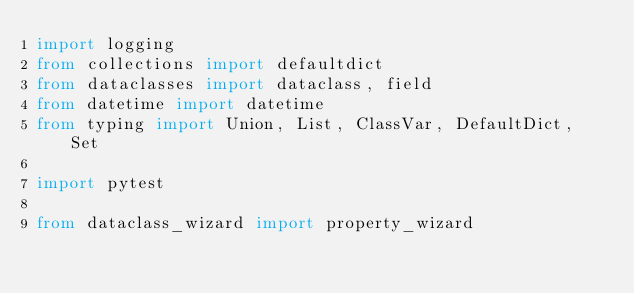<code> <loc_0><loc_0><loc_500><loc_500><_Python_>import logging
from collections import defaultdict
from dataclasses import dataclass, field
from datetime import datetime
from typing import Union, List, ClassVar, DefaultDict, Set

import pytest

from dataclass_wizard import property_wizard</code> 